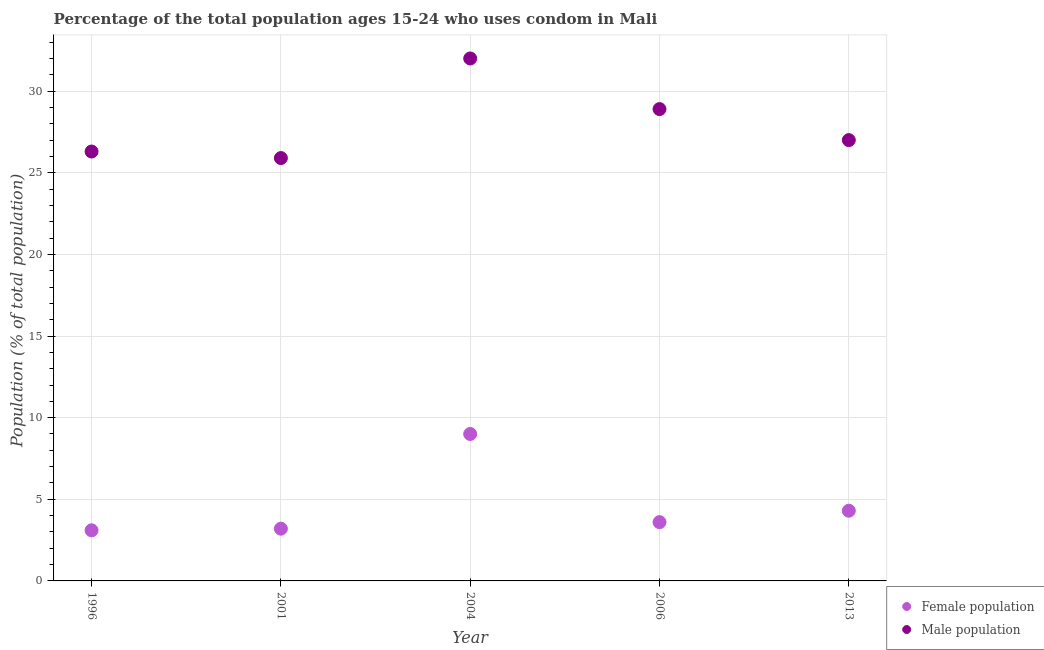How many different coloured dotlines are there?
Keep it short and to the point. 2. Across all years, what is the minimum male population?
Keep it short and to the point. 25.9. In which year was the male population maximum?
Give a very brief answer. 2004. In which year was the male population minimum?
Ensure brevity in your answer.  2001. What is the total female population in the graph?
Your response must be concise. 23.2. What is the difference between the male population in 2006 and that in 2013?
Make the answer very short. 1.9. What is the difference between the female population in 2001 and the male population in 2006?
Your answer should be compact. -25.7. What is the average female population per year?
Your answer should be compact. 4.64. In the year 1996, what is the difference between the female population and male population?
Keep it short and to the point. -23.2. In how many years, is the female population greater than 4 %?
Ensure brevity in your answer.  2. What is the ratio of the female population in 2001 to that in 2004?
Provide a succinct answer. 0.36. Is the male population in 2001 less than that in 2004?
Give a very brief answer. Yes. Is the difference between the female population in 2001 and 2006 greater than the difference between the male population in 2001 and 2006?
Keep it short and to the point. Yes. What is the difference between the highest and the second highest male population?
Ensure brevity in your answer.  3.1. What is the difference between the highest and the lowest female population?
Offer a terse response. 5.9. In how many years, is the male population greater than the average male population taken over all years?
Your response must be concise. 2. Does the female population monotonically increase over the years?
Your answer should be very brief. No. Is the female population strictly greater than the male population over the years?
Offer a very short reply. No. What is the difference between two consecutive major ticks on the Y-axis?
Your response must be concise. 5. Are the values on the major ticks of Y-axis written in scientific E-notation?
Provide a short and direct response. No. Does the graph contain grids?
Ensure brevity in your answer.  Yes. Where does the legend appear in the graph?
Offer a terse response. Bottom right. What is the title of the graph?
Provide a succinct answer. Percentage of the total population ages 15-24 who uses condom in Mali. Does "Under-five" appear as one of the legend labels in the graph?
Keep it short and to the point. No. What is the label or title of the X-axis?
Keep it short and to the point. Year. What is the label or title of the Y-axis?
Make the answer very short. Population (% of total population) . What is the Population (% of total population)  of Male population in 1996?
Make the answer very short. 26.3. What is the Population (% of total population)  in Female population in 2001?
Your answer should be compact. 3.2. What is the Population (% of total population)  in Male population in 2001?
Provide a succinct answer. 25.9. What is the Population (% of total population)  in Male population in 2004?
Your answer should be very brief. 32. What is the Population (% of total population)  in Female population in 2006?
Offer a terse response. 3.6. What is the Population (% of total population)  in Male population in 2006?
Your answer should be compact. 28.9. Across all years, what is the maximum Population (% of total population)  in Male population?
Provide a short and direct response. 32. Across all years, what is the minimum Population (% of total population)  of Female population?
Provide a short and direct response. 3.1. Across all years, what is the minimum Population (% of total population)  in Male population?
Provide a succinct answer. 25.9. What is the total Population (% of total population)  of Female population in the graph?
Your answer should be very brief. 23.2. What is the total Population (% of total population)  in Male population in the graph?
Offer a terse response. 140.1. What is the difference between the Population (% of total population)  of Female population in 1996 and that in 2001?
Your answer should be very brief. -0.1. What is the difference between the Population (% of total population)  of Male population in 1996 and that in 2001?
Your answer should be very brief. 0.4. What is the difference between the Population (% of total population)  in Female population in 2001 and that in 2006?
Your answer should be very brief. -0.4. What is the difference between the Population (% of total population)  of Male population in 2001 and that in 2006?
Offer a terse response. -3. What is the difference between the Population (% of total population)  in Female population in 2001 and that in 2013?
Offer a very short reply. -1.1. What is the difference between the Population (% of total population)  in Female population in 2004 and that in 2006?
Give a very brief answer. 5.4. What is the difference between the Population (% of total population)  of Female population in 2004 and that in 2013?
Offer a terse response. 4.7. What is the difference between the Population (% of total population)  in Female population in 2006 and that in 2013?
Your answer should be compact. -0.7. What is the difference between the Population (% of total population)  in Female population in 1996 and the Population (% of total population)  in Male population in 2001?
Offer a very short reply. -22.8. What is the difference between the Population (% of total population)  in Female population in 1996 and the Population (% of total population)  in Male population in 2004?
Offer a very short reply. -28.9. What is the difference between the Population (% of total population)  of Female population in 1996 and the Population (% of total population)  of Male population in 2006?
Give a very brief answer. -25.8. What is the difference between the Population (% of total population)  in Female population in 1996 and the Population (% of total population)  in Male population in 2013?
Provide a short and direct response. -23.9. What is the difference between the Population (% of total population)  of Female population in 2001 and the Population (% of total population)  of Male population in 2004?
Offer a very short reply. -28.8. What is the difference between the Population (% of total population)  in Female population in 2001 and the Population (% of total population)  in Male population in 2006?
Make the answer very short. -25.7. What is the difference between the Population (% of total population)  in Female population in 2001 and the Population (% of total population)  in Male population in 2013?
Your answer should be very brief. -23.8. What is the difference between the Population (% of total population)  in Female population in 2004 and the Population (% of total population)  in Male population in 2006?
Offer a very short reply. -19.9. What is the difference between the Population (% of total population)  of Female population in 2006 and the Population (% of total population)  of Male population in 2013?
Provide a succinct answer. -23.4. What is the average Population (% of total population)  in Female population per year?
Provide a short and direct response. 4.64. What is the average Population (% of total population)  of Male population per year?
Keep it short and to the point. 28.02. In the year 1996, what is the difference between the Population (% of total population)  in Female population and Population (% of total population)  in Male population?
Your response must be concise. -23.2. In the year 2001, what is the difference between the Population (% of total population)  of Female population and Population (% of total population)  of Male population?
Give a very brief answer. -22.7. In the year 2006, what is the difference between the Population (% of total population)  of Female population and Population (% of total population)  of Male population?
Offer a very short reply. -25.3. In the year 2013, what is the difference between the Population (% of total population)  of Female population and Population (% of total population)  of Male population?
Your response must be concise. -22.7. What is the ratio of the Population (% of total population)  of Female population in 1996 to that in 2001?
Your answer should be compact. 0.97. What is the ratio of the Population (% of total population)  in Male population in 1996 to that in 2001?
Your response must be concise. 1.02. What is the ratio of the Population (% of total population)  of Female population in 1996 to that in 2004?
Give a very brief answer. 0.34. What is the ratio of the Population (% of total population)  of Male population in 1996 to that in 2004?
Ensure brevity in your answer.  0.82. What is the ratio of the Population (% of total population)  of Female population in 1996 to that in 2006?
Your response must be concise. 0.86. What is the ratio of the Population (% of total population)  in Male population in 1996 to that in 2006?
Provide a short and direct response. 0.91. What is the ratio of the Population (% of total population)  of Female population in 1996 to that in 2013?
Give a very brief answer. 0.72. What is the ratio of the Population (% of total population)  of Male population in 1996 to that in 2013?
Your answer should be compact. 0.97. What is the ratio of the Population (% of total population)  in Female population in 2001 to that in 2004?
Your response must be concise. 0.36. What is the ratio of the Population (% of total population)  of Male population in 2001 to that in 2004?
Make the answer very short. 0.81. What is the ratio of the Population (% of total population)  in Female population in 2001 to that in 2006?
Provide a succinct answer. 0.89. What is the ratio of the Population (% of total population)  in Male population in 2001 to that in 2006?
Keep it short and to the point. 0.9. What is the ratio of the Population (% of total population)  of Female population in 2001 to that in 2013?
Provide a succinct answer. 0.74. What is the ratio of the Population (% of total population)  of Male population in 2001 to that in 2013?
Offer a terse response. 0.96. What is the ratio of the Population (% of total population)  of Female population in 2004 to that in 2006?
Ensure brevity in your answer.  2.5. What is the ratio of the Population (% of total population)  in Male population in 2004 to that in 2006?
Provide a succinct answer. 1.11. What is the ratio of the Population (% of total population)  in Female population in 2004 to that in 2013?
Make the answer very short. 2.09. What is the ratio of the Population (% of total population)  of Male population in 2004 to that in 2013?
Give a very brief answer. 1.19. What is the ratio of the Population (% of total population)  of Female population in 2006 to that in 2013?
Your response must be concise. 0.84. What is the ratio of the Population (% of total population)  of Male population in 2006 to that in 2013?
Your response must be concise. 1.07. 